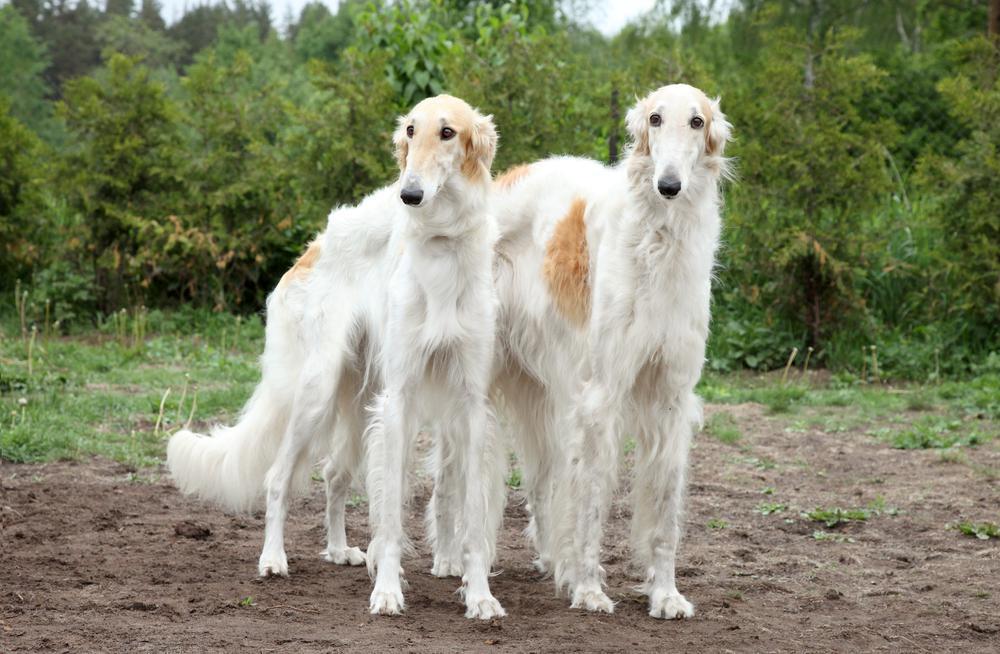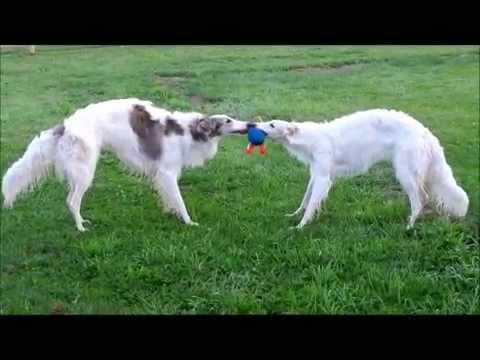The first image is the image on the left, the second image is the image on the right. Analyze the images presented: Is the assertion "There are the same number of hounds in the left and right images." valid? Answer yes or no. Yes. The first image is the image on the left, the second image is the image on the right. Analyze the images presented: Is the assertion "There is only one dog in each picture." valid? Answer yes or no. No. 